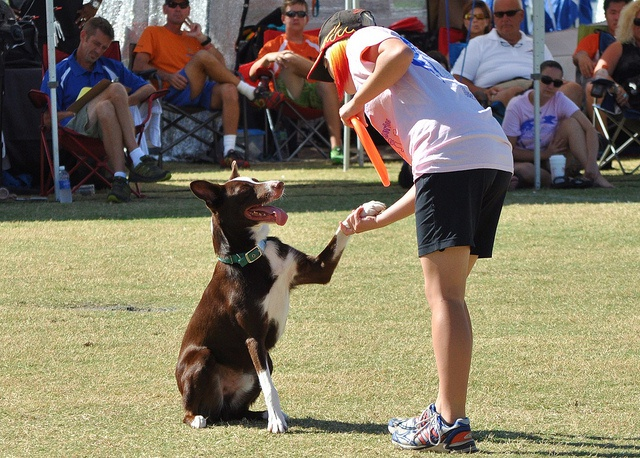Describe the objects in this image and their specific colors. I can see people in black, darkgray, white, and brown tones, dog in black, maroon, darkgray, and gray tones, people in black, navy, gray, and maroon tones, people in black, maroon, and brown tones, and people in black and gray tones in this image. 